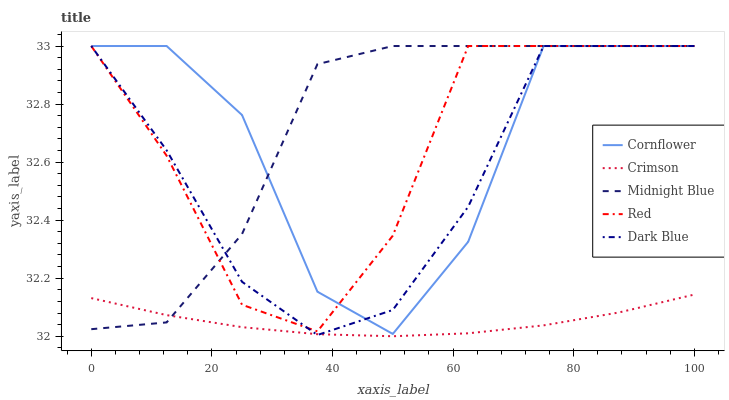Does Crimson have the minimum area under the curve?
Answer yes or no. Yes. Does Midnight Blue have the maximum area under the curve?
Answer yes or no. Yes. Does Cornflower have the minimum area under the curve?
Answer yes or no. No. Does Cornflower have the maximum area under the curve?
Answer yes or no. No. Is Crimson the smoothest?
Answer yes or no. Yes. Is Cornflower the roughest?
Answer yes or no. Yes. Is Midnight Blue the smoothest?
Answer yes or no. No. Is Midnight Blue the roughest?
Answer yes or no. No. Does Crimson have the lowest value?
Answer yes or no. Yes. Does Cornflower have the lowest value?
Answer yes or no. No. Does Dark Blue have the highest value?
Answer yes or no. Yes. Is Crimson less than Cornflower?
Answer yes or no. Yes. Is Cornflower greater than Crimson?
Answer yes or no. Yes. Does Cornflower intersect Dark Blue?
Answer yes or no. Yes. Is Cornflower less than Dark Blue?
Answer yes or no. No. Is Cornflower greater than Dark Blue?
Answer yes or no. No. Does Crimson intersect Cornflower?
Answer yes or no. No. 